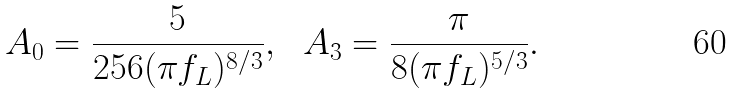<formula> <loc_0><loc_0><loc_500><loc_500>A _ { 0 } = \frac { 5 } { 2 5 6 ( \pi f _ { L } ) ^ { 8 / 3 } } , \ \ A _ { 3 } = \frac { \pi } { 8 ( \pi f _ { L } ) ^ { 5 / 3 } } .</formula> 